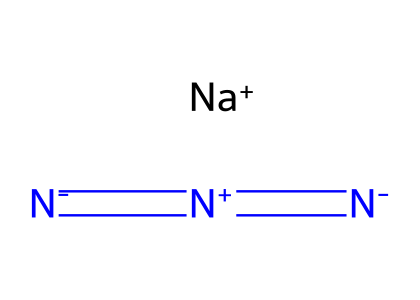What is the molecular formula of sodium azide? The SMILES representation indicates one sodium (Na) atom and three nitrogen (N) atoms, which combines to give the molecular formula NaN3.
Answer: NaN3 How many nitrogen atoms are present in sodium azide? From the SMILES notation, there are three nitrogen atoms connected in the structure, represented as N, N, and N.
Answer: three What is the charge of the sodium ion in sodium azide? The notation [Na+] indicates that the sodium ion has a positive charge, typically found in ionic compounds.
Answer: positive What type of chemical bond connects the nitrogen atoms in sodium azide? The structure indicates double bonds between the nitrogen atoms, as shown by the "=" signs in the SMILES.
Answer: double bonds Why is sodium azide considered an azide? The compound contains a functional group represented by N=N=N (three connected nitrogen atoms), which is characteristic of azides.
Answer: three nitrogen atoms What role does sodium azide play in airbags? Sodium azide decomposes rapidly to produce nitrogen gas when ignited, which inflates the airbag in a crash.
Answer: nitrogen gas In which type of reaction is sodium azide typically involved in airbags? Sodium azide undergoes a decomposition reaction when triggered, producing nitrogen gas as a product.
Answer: decomposition reaction 